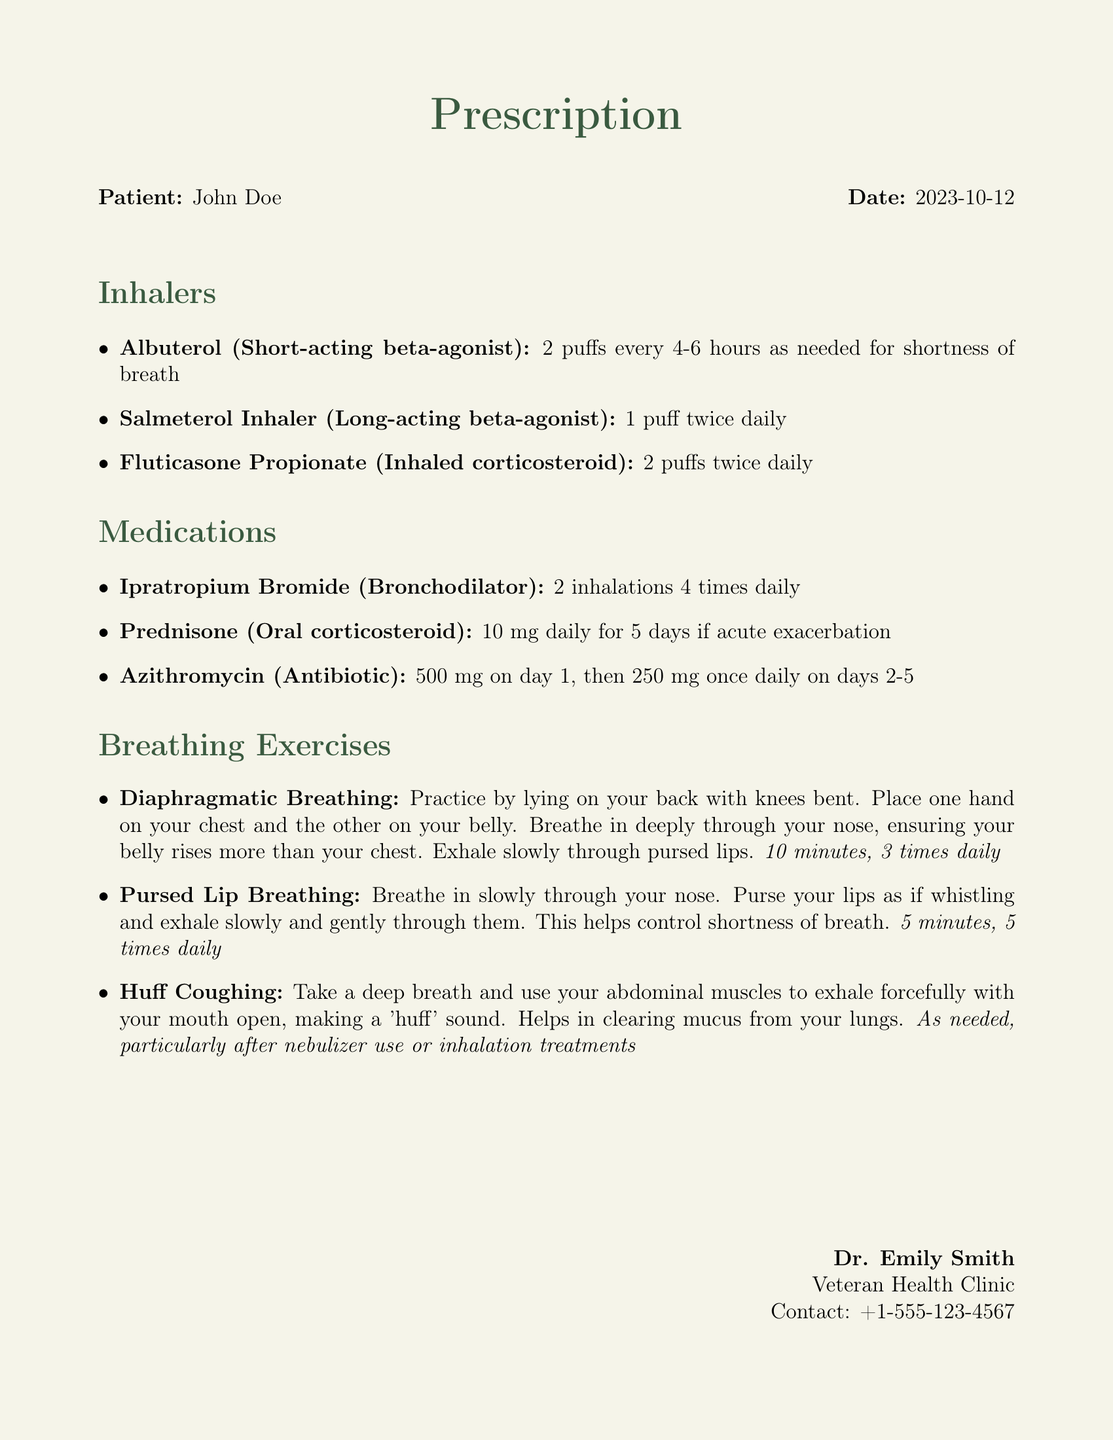What is the name of the patient? The patient's name is mentioned at the beginning of the document.
Answer: John Doe What is the date of the prescription? The date is explicitly stated at the top of the document.
Answer: 2023-10-12 How many puffs of Albuterol should be taken every 4-6 hours? This information is provided in the inhalers section regarding Albuterol usage.
Answer: 2 puffs What is the dosage for Prednisone during an acute exacerbation? The specific dosage is outlined in the medications section for Prednisone.
Answer: 10 mg daily for 5 days How often should diaphragmatic breathing exercises be practiced? The frequency for the diaphragmatic breathing exercise is detailed in the breathing exercises section.
Answer: 3 times daily What is the breathing technique recommended for controlling shortness of breath? This technique is described in the breathing exercises section.
Answer: Pursed Lip Breathing What is the contact number for Dr. Emily Smith? The contact information for Dr. Emily Smith is provided in the document's footer.
Answer: +1-555-123-4567 How many times daily should the Fluticasone Propionate inhaler be used? This information is found in the inhalers section regarding the usage of Fluticasone Propionate.
Answer: 2 puffs twice daily What action is involved in Huff Coughing? The action associated with Huff Coughing is specified in the breathing exercises.
Answer: Exhale forcefully with mouth open making a 'huff' sound What type of medication is Azithromycin? This detail is identified in the medications section outlining Azithromycin.
Answer: Antibiotic 